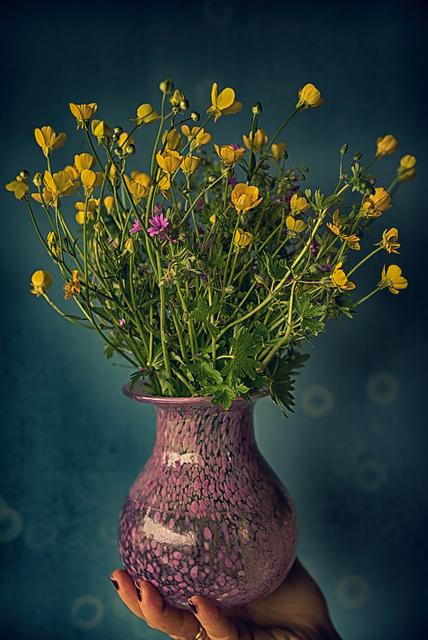Are all the flowers the same color?
Be succinct. No. Is the flower wilted?
Short answer required. No. Where is the vase?
Give a very brief answer. In hand. What is the main color of the vase?
Write a very short answer. Pink. What color is the flower vase?
Write a very short answer. Pink. What is holding the vase upright?
Answer briefly. Hand. Is this case handmade?
Give a very brief answer. No. Is the background in focus?
Write a very short answer. No. What is the color of the flowers?
Keep it brief. Yellow. 